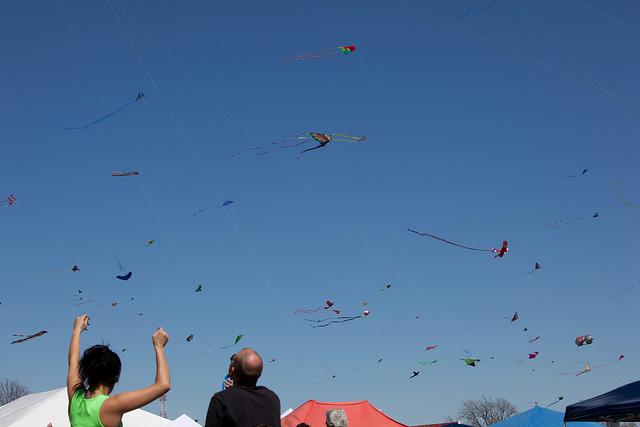Is it cold?
Short answer required. No. Are they hugging?
Answer briefly. No. Is there a plane in the air?
Keep it brief. No. Does this person have a better than average chance of suffering a grievous injury?
Give a very brief answer. No. What is the man doing?
Quick response, please. Flying kite. What is in the sky?
Answer briefly. Kites. Are there birds perched?
Give a very brief answer. No. Are they related?
Concise answer only. Yes. What is in the air?
Concise answer only. Kites. How many people are in the picture?
Keep it brief. 3. What color is the woman on the left wearing?
Quick response, please. Green. 